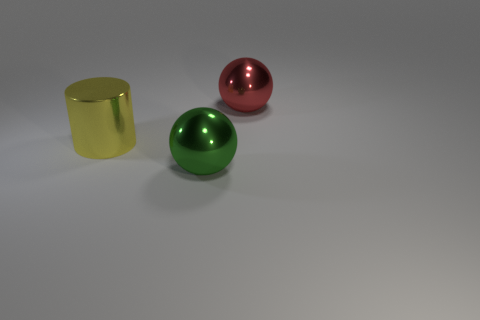Are there any yellow cylinders left of the metallic cylinder?
Provide a succinct answer. No. Is the shape of the shiny thing that is right of the large green shiny ball the same as  the large green object?
Give a very brief answer. Yes. How many large balls are the same color as the metal cylinder?
Your response must be concise. 0. There is a metal thing that is on the right side of the large shiny sphere in front of the red metallic object; what shape is it?
Make the answer very short. Sphere. Are there any other large yellow things that have the same shape as the yellow metallic thing?
Your answer should be very brief. No. There is a shiny cylinder; does it have the same color as the shiny object in front of the large metallic cylinder?
Make the answer very short. No. Is there a green metal sphere that has the same size as the red object?
Make the answer very short. Yes. Do the large cylinder and the large sphere that is in front of the yellow shiny object have the same material?
Make the answer very short. Yes. Is the number of objects greater than the number of red things?
Offer a terse response. Yes. What number of spheres are big green things or yellow shiny things?
Give a very brief answer. 1. 